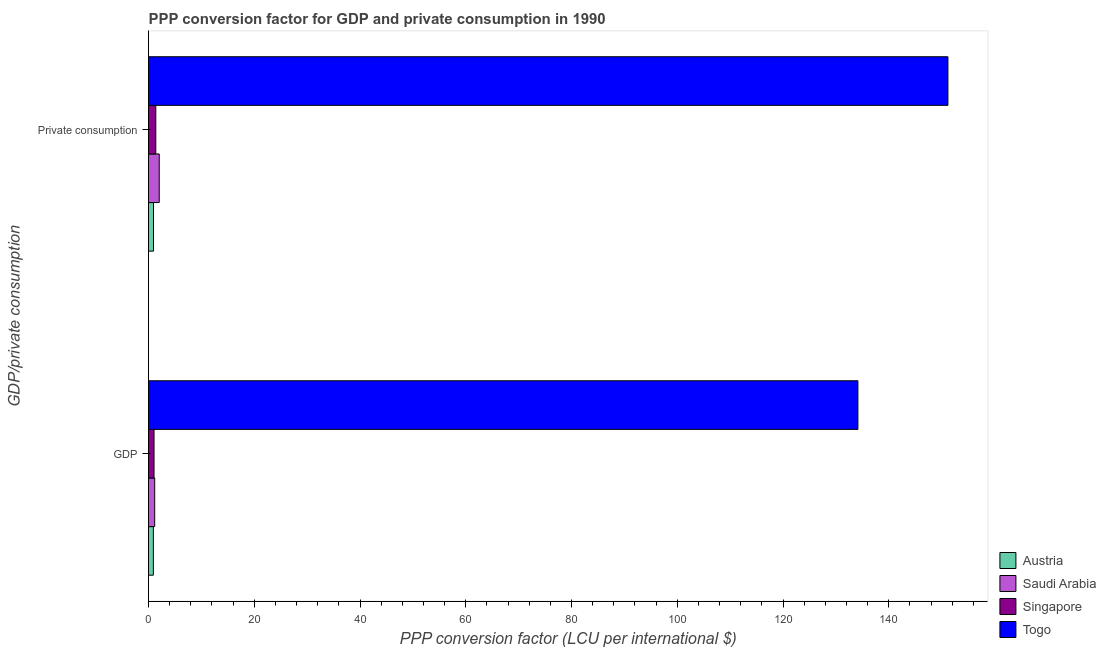How many different coloured bars are there?
Ensure brevity in your answer.  4. Are the number of bars per tick equal to the number of legend labels?
Keep it short and to the point. Yes. Are the number of bars on each tick of the Y-axis equal?
Your answer should be compact. Yes. What is the label of the 1st group of bars from the top?
Ensure brevity in your answer.   Private consumption. What is the ppp conversion factor for private consumption in Togo?
Offer a terse response. 151.19. Across all countries, what is the maximum ppp conversion factor for gdp?
Keep it short and to the point. 134.16. Across all countries, what is the minimum ppp conversion factor for gdp?
Your answer should be compact. 0.92. In which country was the ppp conversion factor for private consumption maximum?
Offer a very short reply. Togo. What is the total ppp conversion factor for gdp in the graph?
Provide a short and direct response. 137.29. What is the difference between the ppp conversion factor for gdp in Singapore and that in Togo?
Provide a short and direct response. -133.12. What is the difference between the ppp conversion factor for private consumption in Austria and the ppp conversion factor for gdp in Togo?
Your response must be concise. -133.22. What is the average ppp conversion factor for private consumption per country?
Provide a short and direct response. 38.88. What is the difference between the ppp conversion factor for private consumption and ppp conversion factor for gdp in Singapore?
Offer a terse response. 0.33. In how many countries, is the ppp conversion factor for gdp greater than 140 LCU?
Offer a very short reply. 0. What is the ratio of the ppp conversion factor for private consumption in Togo to that in Singapore?
Your answer should be compact. 109.84. In how many countries, is the ppp conversion factor for gdp greater than the average ppp conversion factor for gdp taken over all countries?
Provide a short and direct response. 1. What does the 3rd bar from the top in  Private consumption represents?
Your answer should be very brief. Saudi Arabia. What does the 4th bar from the bottom in  Private consumption represents?
Ensure brevity in your answer.  Togo. How many bars are there?
Your response must be concise. 8. Are all the bars in the graph horizontal?
Offer a very short reply. Yes. What is the difference between two consecutive major ticks on the X-axis?
Offer a very short reply. 20. How many legend labels are there?
Keep it short and to the point. 4. What is the title of the graph?
Make the answer very short. PPP conversion factor for GDP and private consumption in 1990. Does "Tonga" appear as one of the legend labels in the graph?
Offer a very short reply. No. What is the label or title of the X-axis?
Make the answer very short. PPP conversion factor (LCU per international $). What is the label or title of the Y-axis?
Provide a succinct answer. GDP/private consumption. What is the PPP conversion factor (LCU per international $) of Austria in GDP?
Provide a short and direct response. 0.92. What is the PPP conversion factor (LCU per international $) of Saudi Arabia in GDP?
Make the answer very short. 1.17. What is the PPP conversion factor (LCU per international $) in Singapore in GDP?
Your response must be concise. 1.04. What is the PPP conversion factor (LCU per international $) of Togo in GDP?
Ensure brevity in your answer.  134.16. What is the PPP conversion factor (LCU per international $) of Austria in  Private consumption?
Offer a very short reply. 0.94. What is the PPP conversion factor (LCU per international $) of Saudi Arabia in  Private consumption?
Offer a terse response. 2.03. What is the PPP conversion factor (LCU per international $) of Singapore in  Private consumption?
Offer a very short reply. 1.38. What is the PPP conversion factor (LCU per international $) in Togo in  Private consumption?
Ensure brevity in your answer.  151.19. Across all GDP/private consumption, what is the maximum PPP conversion factor (LCU per international $) of Austria?
Provide a succinct answer. 0.94. Across all GDP/private consumption, what is the maximum PPP conversion factor (LCU per international $) of Saudi Arabia?
Ensure brevity in your answer.  2.03. Across all GDP/private consumption, what is the maximum PPP conversion factor (LCU per international $) in Singapore?
Your answer should be compact. 1.38. Across all GDP/private consumption, what is the maximum PPP conversion factor (LCU per international $) of Togo?
Make the answer very short. 151.19. Across all GDP/private consumption, what is the minimum PPP conversion factor (LCU per international $) in Austria?
Make the answer very short. 0.92. Across all GDP/private consumption, what is the minimum PPP conversion factor (LCU per international $) in Saudi Arabia?
Make the answer very short. 1.17. Across all GDP/private consumption, what is the minimum PPP conversion factor (LCU per international $) of Singapore?
Offer a terse response. 1.04. Across all GDP/private consumption, what is the minimum PPP conversion factor (LCU per international $) in Togo?
Provide a succinct answer. 134.16. What is the total PPP conversion factor (LCU per international $) of Austria in the graph?
Provide a succinct answer. 1.86. What is the total PPP conversion factor (LCU per international $) in Saudi Arabia in the graph?
Provide a succinct answer. 3.2. What is the total PPP conversion factor (LCU per international $) of Singapore in the graph?
Make the answer very short. 2.42. What is the total PPP conversion factor (LCU per international $) of Togo in the graph?
Offer a very short reply. 285.35. What is the difference between the PPP conversion factor (LCU per international $) in Austria in GDP and that in  Private consumption?
Offer a terse response. -0.03. What is the difference between the PPP conversion factor (LCU per international $) in Saudi Arabia in GDP and that in  Private consumption?
Make the answer very short. -0.86. What is the difference between the PPP conversion factor (LCU per international $) of Singapore in GDP and that in  Private consumption?
Your response must be concise. -0.33. What is the difference between the PPP conversion factor (LCU per international $) in Togo in GDP and that in  Private consumption?
Provide a short and direct response. -17.02. What is the difference between the PPP conversion factor (LCU per international $) of Austria in GDP and the PPP conversion factor (LCU per international $) of Saudi Arabia in  Private consumption?
Your answer should be very brief. -1.11. What is the difference between the PPP conversion factor (LCU per international $) of Austria in GDP and the PPP conversion factor (LCU per international $) of Singapore in  Private consumption?
Offer a terse response. -0.46. What is the difference between the PPP conversion factor (LCU per international $) of Austria in GDP and the PPP conversion factor (LCU per international $) of Togo in  Private consumption?
Provide a succinct answer. -150.27. What is the difference between the PPP conversion factor (LCU per international $) in Saudi Arabia in GDP and the PPP conversion factor (LCU per international $) in Singapore in  Private consumption?
Offer a very short reply. -0.21. What is the difference between the PPP conversion factor (LCU per international $) in Saudi Arabia in GDP and the PPP conversion factor (LCU per international $) in Togo in  Private consumption?
Offer a terse response. -150.02. What is the difference between the PPP conversion factor (LCU per international $) in Singapore in GDP and the PPP conversion factor (LCU per international $) in Togo in  Private consumption?
Make the answer very short. -150.15. What is the average PPP conversion factor (LCU per international $) in Austria per GDP/private consumption?
Provide a short and direct response. 0.93. What is the average PPP conversion factor (LCU per international $) in Saudi Arabia per GDP/private consumption?
Your answer should be compact. 1.6. What is the average PPP conversion factor (LCU per international $) of Singapore per GDP/private consumption?
Make the answer very short. 1.21. What is the average PPP conversion factor (LCU per international $) of Togo per GDP/private consumption?
Offer a very short reply. 142.68. What is the difference between the PPP conversion factor (LCU per international $) in Austria and PPP conversion factor (LCU per international $) in Saudi Arabia in GDP?
Keep it short and to the point. -0.25. What is the difference between the PPP conversion factor (LCU per international $) in Austria and PPP conversion factor (LCU per international $) in Singapore in GDP?
Provide a short and direct response. -0.13. What is the difference between the PPP conversion factor (LCU per international $) in Austria and PPP conversion factor (LCU per international $) in Togo in GDP?
Offer a terse response. -133.25. What is the difference between the PPP conversion factor (LCU per international $) of Saudi Arabia and PPP conversion factor (LCU per international $) of Singapore in GDP?
Offer a terse response. 0.13. What is the difference between the PPP conversion factor (LCU per international $) in Saudi Arabia and PPP conversion factor (LCU per international $) in Togo in GDP?
Keep it short and to the point. -132.99. What is the difference between the PPP conversion factor (LCU per international $) in Singapore and PPP conversion factor (LCU per international $) in Togo in GDP?
Make the answer very short. -133.12. What is the difference between the PPP conversion factor (LCU per international $) in Austria and PPP conversion factor (LCU per international $) in Saudi Arabia in  Private consumption?
Your answer should be compact. -1.09. What is the difference between the PPP conversion factor (LCU per international $) in Austria and PPP conversion factor (LCU per international $) in Singapore in  Private consumption?
Make the answer very short. -0.44. What is the difference between the PPP conversion factor (LCU per international $) in Austria and PPP conversion factor (LCU per international $) in Togo in  Private consumption?
Provide a short and direct response. -150.25. What is the difference between the PPP conversion factor (LCU per international $) in Saudi Arabia and PPP conversion factor (LCU per international $) in Singapore in  Private consumption?
Your answer should be very brief. 0.65. What is the difference between the PPP conversion factor (LCU per international $) in Saudi Arabia and PPP conversion factor (LCU per international $) in Togo in  Private consumption?
Your response must be concise. -149.16. What is the difference between the PPP conversion factor (LCU per international $) of Singapore and PPP conversion factor (LCU per international $) of Togo in  Private consumption?
Provide a short and direct response. -149.81. What is the ratio of the PPP conversion factor (LCU per international $) of Austria in GDP to that in  Private consumption?
Offer a terse response. 0.97. What is the ratio of the PPP conversion factor (LCU per international $) of Saudi Arabia in GDP to that in  Private consumption?
Your response must be concise. 0.58. What is the ratio of the PPP conversion factor (LCU per international $) of Singapore in GDP to that in  Private consumption?
Offer a terse response. 0.76. What is the ratio of the PPP conversion factor (LCU per international $) in Togo in GDP to that in  Private consumption?
Offer a terse response. 0.89. What is the difference between the highest and the second highest PPP conversion factor (LCU per international $) of Austria?
Make the answer very short. 0.03. What is the difference between the highest and the second highest PPP conversion factor (LCU per international $) in Saudi Arabia?
Your response must be concise. 0.86. What is the difference between the highest and the second highest PPP conversion factor (LCU per international $) in Singapore?
Make the answer very short. 0.33. What is the difference between the highest and the second highest PPP conversion factor (LCU per international $) of Togo?
Give a very brief answer. 17.02. What is the difference between the highest and the lowest PPP conversion factor (LCU per international $) in Austria?
Give a very brief answer. 0.03. What is the difference between the highest and the lowest PPP conversion factor (LCU per international $) of Saudi Arabia?
Your answer should be compact. 0.86. What is the difference between the highest and the lowest PPP conversion factor (LCU per international $) in Singapore?
Provide a succinct answer. 0.33. What is the difference between the highest and the lowest PPP conversion factor (LCU per international $) of Togo?
Provide a succinct answer. 17.02. 